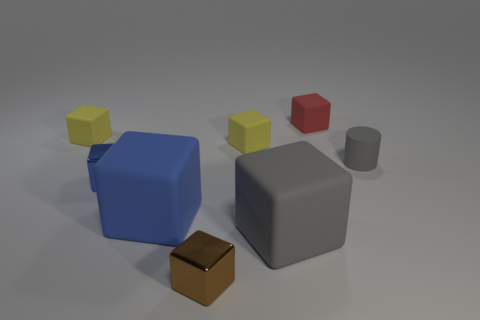Subtract all gray cubes. How many cubes are left? 6 Subtract all blue rubber cubes. How many cubes are left? 6 Subtract all blue blocks. Subtract all gray cylinders. How many blocks are left? 5 Add 2 small objects. How many objects exist? 10 Subtract all cylinders. How many objects are left? 7 Add 3 large rubber blocks. How many large rubber blocks are left? 5 Add 2 metallic cubes. How many metallic cubes exist? 4 Subtract 0 gray balls. How many objects are left? 8 Subtract all purple cylinders. Subtract all small yellow blocks. How many objects are left? 6 